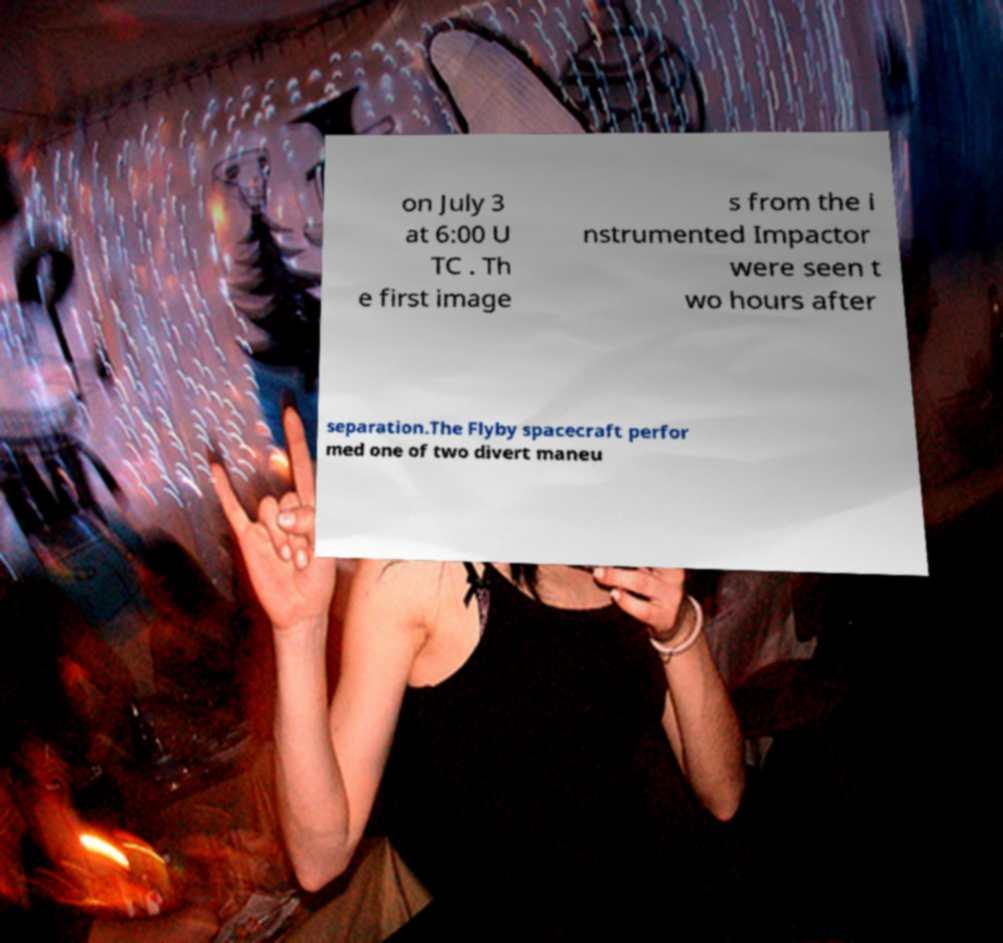What messages or text are displayed in this image? I need them in a readable, typed format. on July 3 at 6:00 U TC . Th e first image s from the i nstrumented Impactor were seen t wo hours after separation.The Flyby spacecraft perfor med one of two divert maneu 